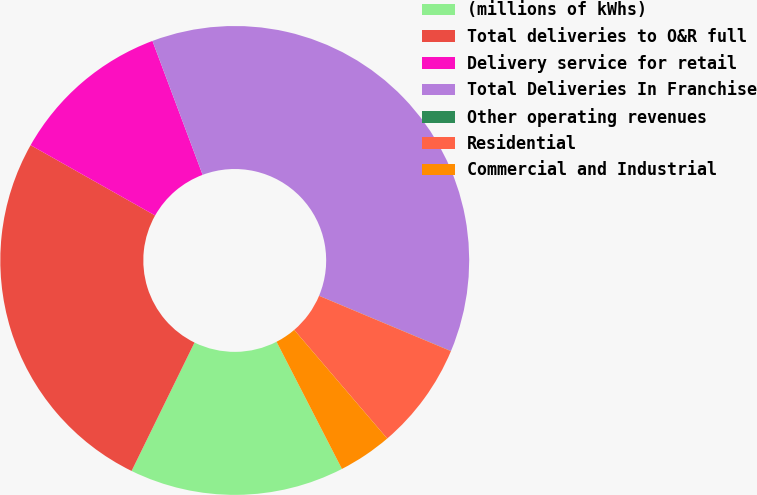Convert chart to OTSL. <chart><loc_0><loc_0><loc_500><loc_500><pie_chart><fcel>(millions of kWhs)<fcel>Total deliveries to O&R full<fcel>Delivery service for retail<fcel>Total Deliveries In Franchise<fcel>Other operating revenues<fcel>Residential<fcel>Commercial and Industrial<nl><fcel>14.81%<fcel>25.93%<fcel>11.11%<fcel>37.02%<fcel>0.01%<fcel>7.41%<fcel>3.71%<nl></chart> 